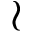Convert formula to latex. <formula><loc_0><loc_0><loc_500><loc_500>\wr</formula> 